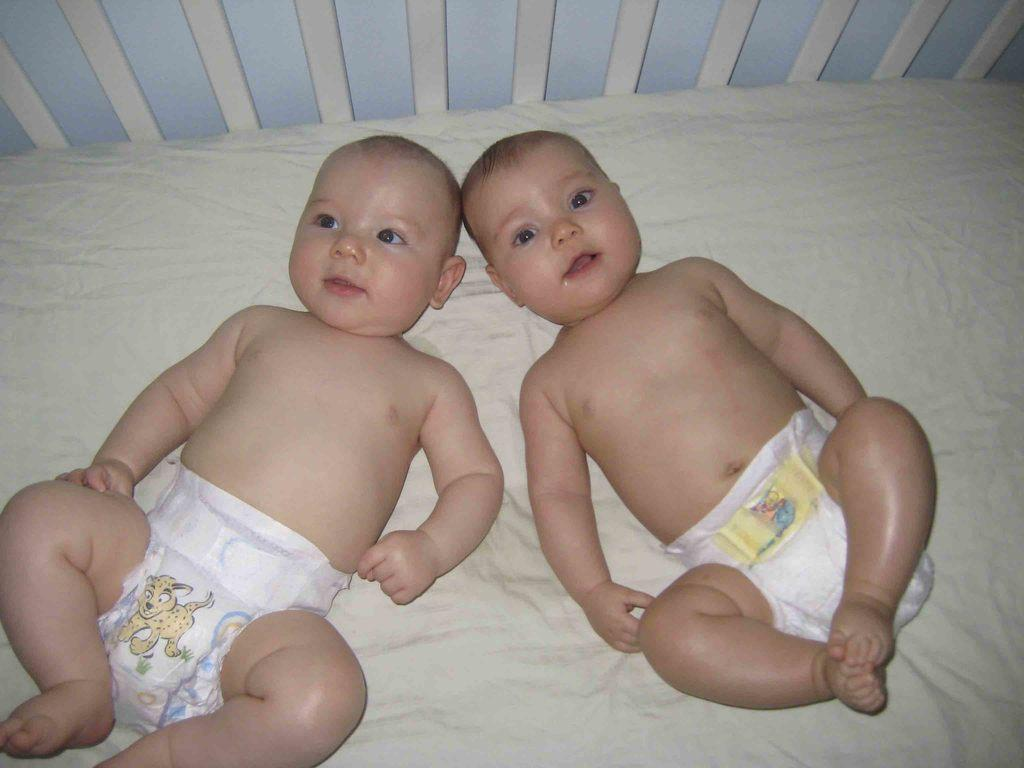How many children are in the image? There are two children in the image. What are the children doing in the image? The children are lying down. What type of clothing are the children wearing? The children are wearing pampers. What can be seen at the bottom of the image? There is a cradle at the bottom of the image. What type of umbrella is the child holding in the image? There is no umbrella present in the image. Is the child playing a guitar in the image? There is no guitar present in the image. 